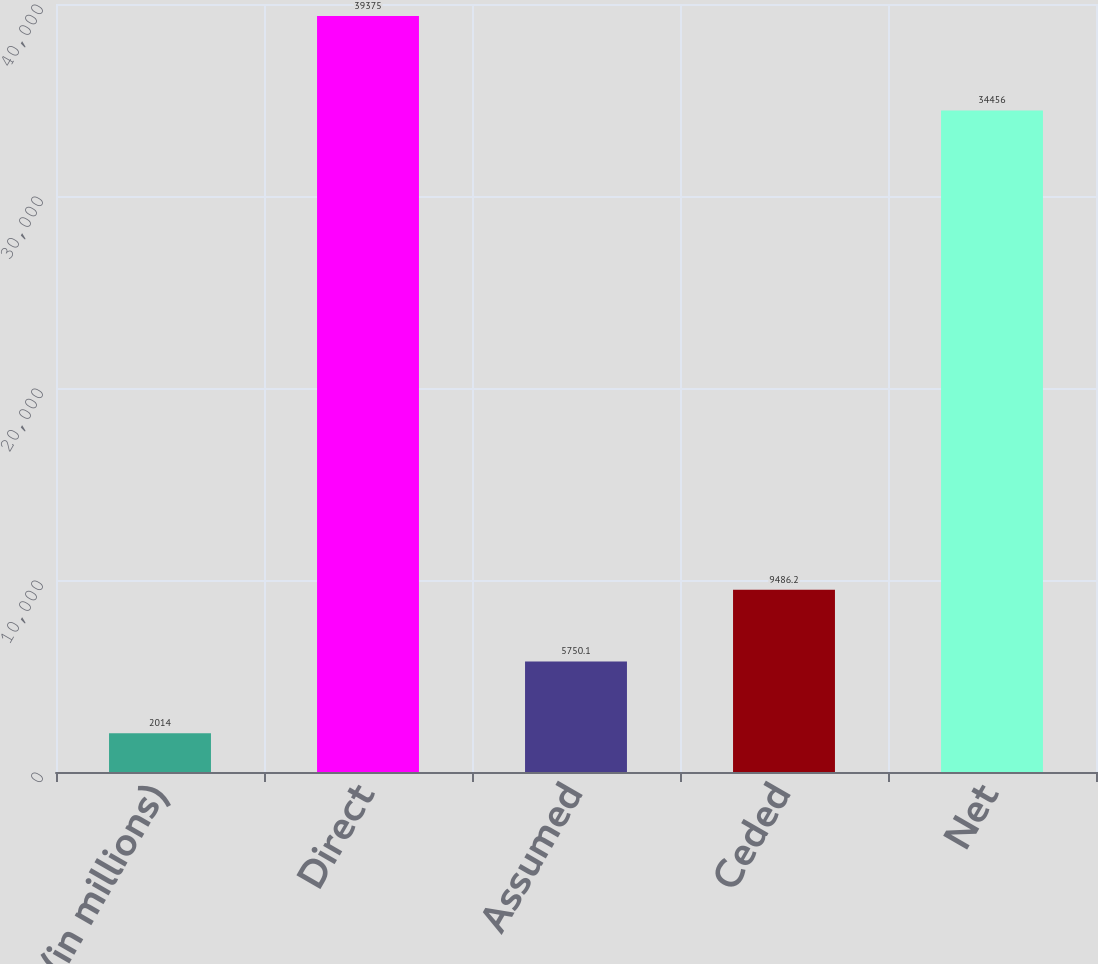Convert chart to OTSL. <chart><loc_0><loc_0><loc_500><loc_500><bar_chart><fcel>(in millions)<fcel>Direct<fcel>Assumed<fcel>Ceded<fcel>Net<nl><fcel>2014<fcel>39375<fcel>5750.1<fcel>9486.2<fcel>34456<nl></chart> 